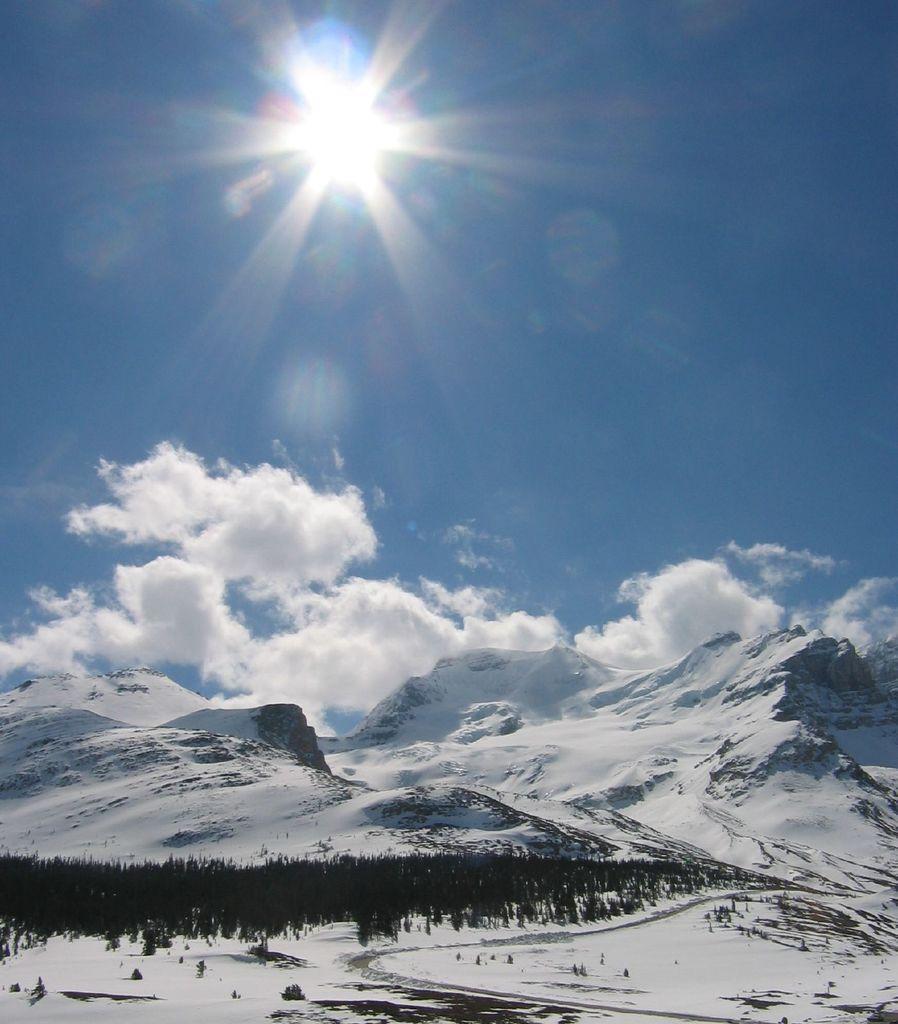Could you give a brief overview of what you see in this image? In this image we can see mountains, trees, clouds, sky and sun. 